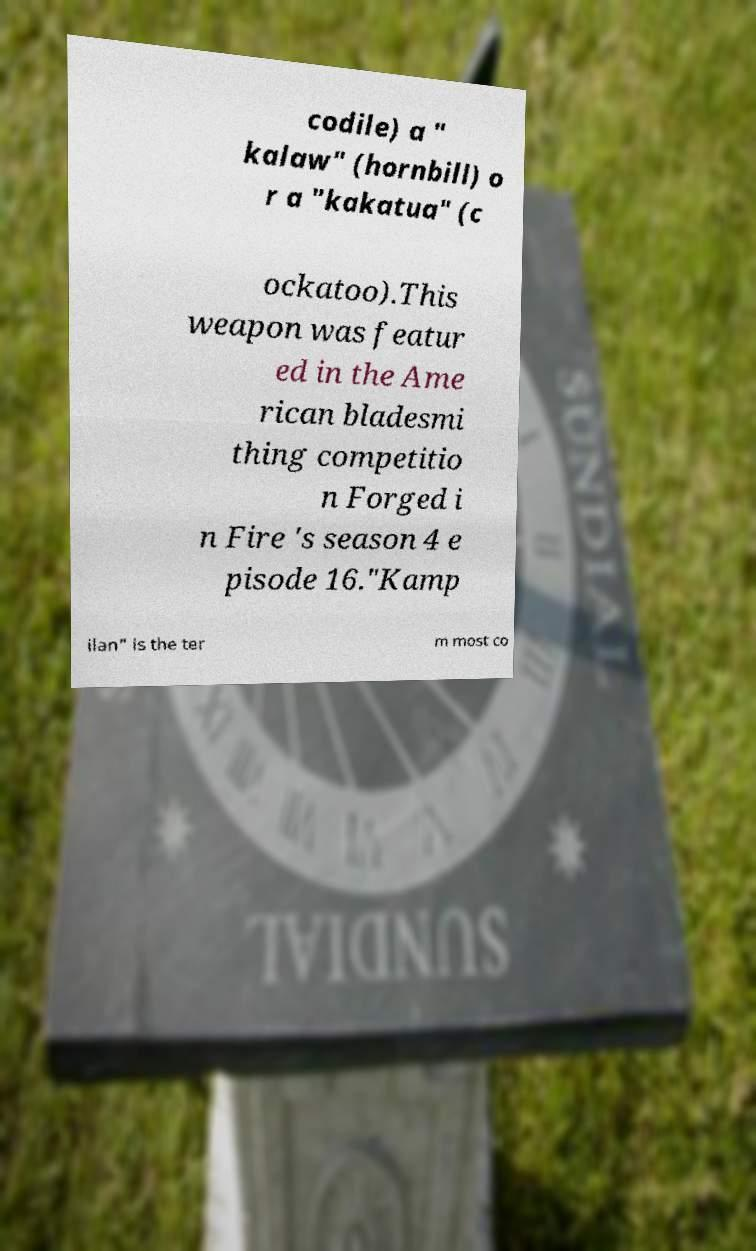For documentation purposes, I need the text within this image transcribed. Could you provide that? codile) a " kalaw" (hornbill) o r a "kakatua" (c ockatoo).This weapon was featur ed in the Ame rican bladesmi thing competitio n Forged i n Fire 's season 4 e pisode 16."Kamp ilan" is the ter m most co 